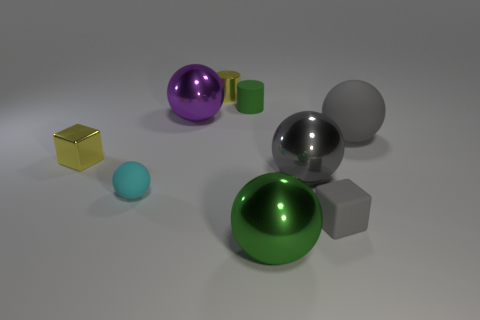Subtract all cyan spheres. How many spheres are left? 4 Subtract all large green balls. How many balls are left? 4 Subtract 2 balls. How many balls are left? 3 Subtract all yellow balls. Subtract all brown blocks. How many balls are left? 5 Add 1 cyan rubber things. How many objects exist? 10 Subtract all spheres. How many objects are left? 4 Add 2 small cyan spheres. How many small cyan spheres are left? 3 Add 8 gray matte blocks. How many gray matte blocks exist? 9 Subtract 0 purple cylinders. How many objects are left? 9 Subtract all big gray matte things. Subtract all gray shiny balls. How many objects are left? 7 